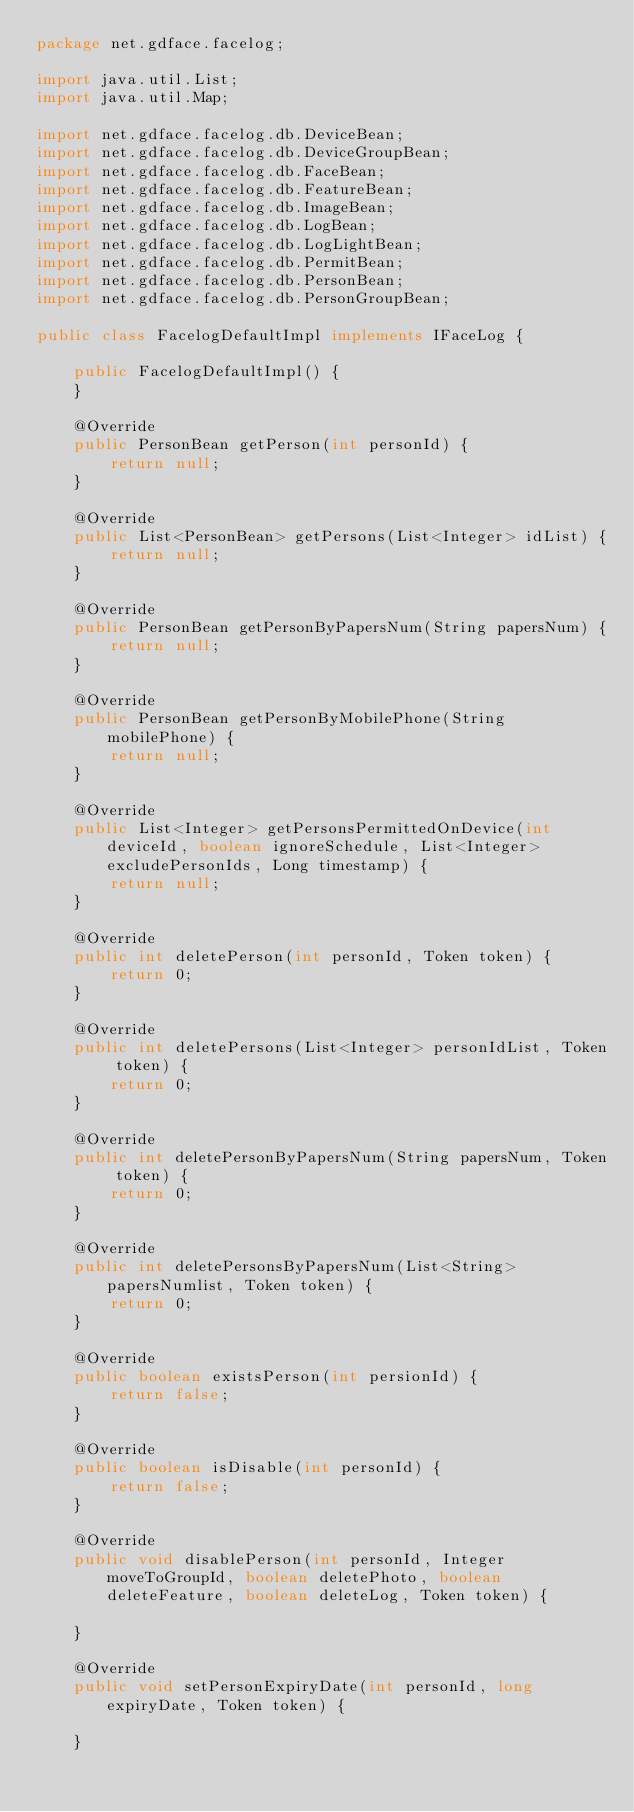<code> <loc_0><loc_0><loc_500><loc_500><_Java_>package net.gdface.facelog;

import java.util.List;
import java.util.Map;

import net.gdface.facelog.db.DeviceBean;
import net.gdface.facelog.db.DeviceGroupBean;
import net.gdface.facelog.db.FaceBean;
import net.gdface.facelog.db.FeatureBean;
import net.gdface.facelog.db.ImageBean;
import net.gdface.facelog.db.LogBean;
import net.gdface.facelog.db.LogLightBean;
import net.gdface.facelog.db.PermitBean;
import net.gdface.facelog.db.PersonBean;
import net.gdface.facelog.db.PersonGroupBean;

public class FacelogDefaultImpl implements IFaceLog {

	public FacelogDefaultImpl() {
	}

	@Override
	public PersonBean getPerson(int personId) {
		return null;
	}

	@Override
	public List<PersonBean> getPersons(List<Integer> idList) {
		return null;
	}

	@Override
	public PersonBean getPersonByPapersNum(String papersNum) {
		return null;
	}

	@Override
	public PersonBean getPersonByMobilePhone(String mobilePhone) {
		return null;
	}
	
	@Override
	public List<Integer> getPersonsPermittedOnDevice(int deviceId, boolean ignoreSchedule, List<Integer> excludePersonIds, Long timestamp) {
		return null;
	}

	@Override
	public int deletePerson(int personId, Token token) {
		return 0;
	}

	@Override
	public int deletePersons(List<Integer> personIdList, Token token) {
		return 0;
	}

	@Override
	public int deletePersonByPapersNum(String papersNum, Token token) {
		return 0;
	}

	@Override
	public int deletePersonsByPapersNum(List<String> papersNumlist, Token token) {
		return 0;
	}

	@Override
	public boolean existsPerson(int persionId) {
		return false;
	}

	@Override
	public boolean isDisable(int personId) {
		return false;
	}

	@Override
	public void disablePerson(int personId, Integer moveToGroupId, boolean deletePhoto, boolean deleteFeature, boolean deleteLog, Token token) {
		
	}

	@Override
	public void setPersonExpiryDate(int personId, long expiryDate, Token token) {
		
	}
</code> 